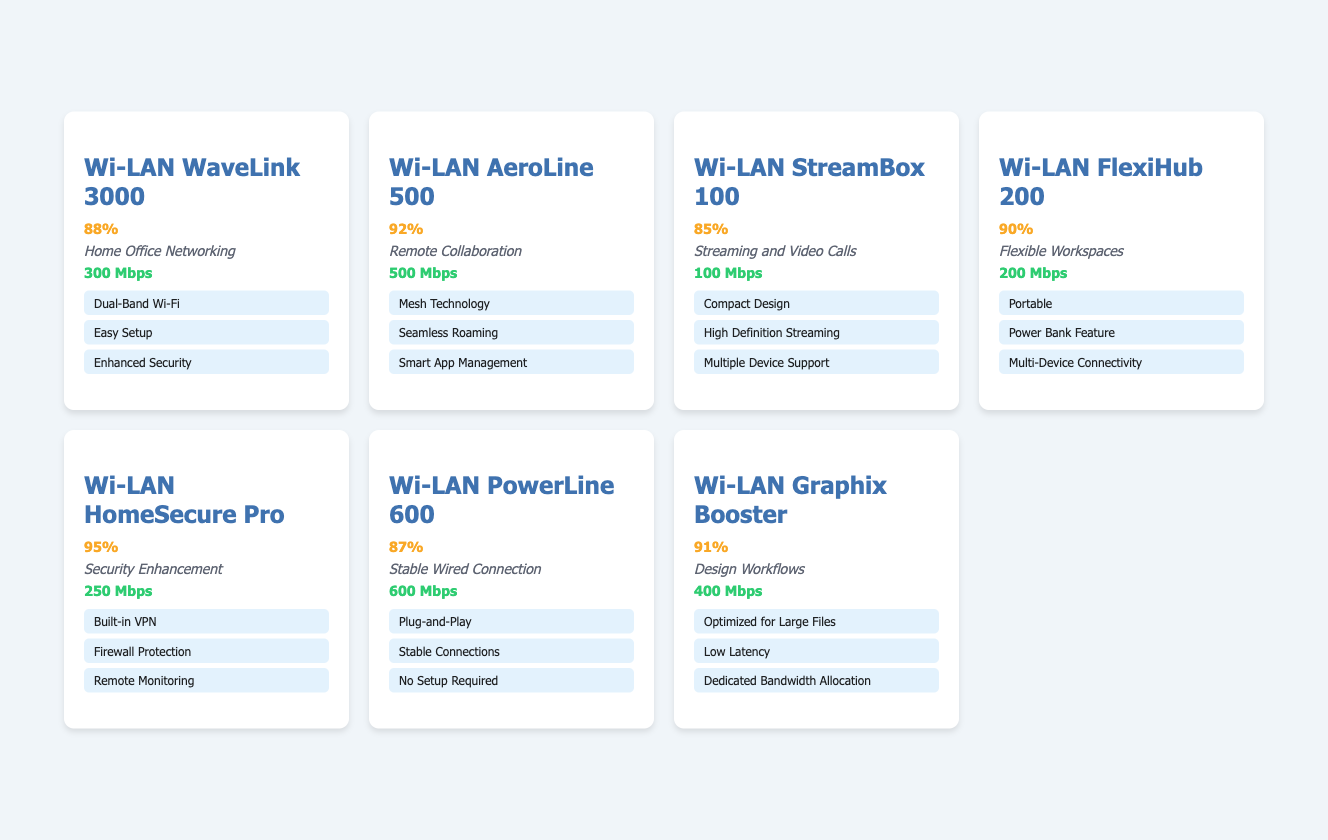What is the customer satisfaction rating for the Wi-LAN HomeSecure Pro? The table shows the customer satisfaction rating for each product. For the Wi-LAN HomeSecure Pro, the rating is presented as 95%.
Answer: 95% Which product has the highest customer satisfaction rating? By comparing the ratings in the table, the highest rating recorded is for the Wi-LAN HomeSecure Pro at 95%.
Answer: Wi-LAN HomeSecure Pro What is the average connectivity speed of the Wi-LAN FlexiHub 200? The average connectivity speed listed for the Wi-LAN FlexiHub 200 in the table is 200 Mbps, as stated next to the product details.
Answer: 200 Mbps How does the customer satisfaction rating of the Wi-LAN Graphix Booster compare to the Wi-LAN PowerLine 600? The customer satisfaction rating for the Wi-LAN Graphix Booster is 91%, while for the Wi-LAN PowerLine 600 it is 87%. The Graphix Booster has a higher rating than the PowerLine 600.
Answer: Higher If you average the customer satisfaction ratings of all products, what is the result? The customer satisfaction ratings are 88, 92, 85, 90, 95, 87, and 91. First, sum these ratings (88 + 92 + 85 + 90 + 95 + 87 + 91 = 718) and then divide by the number of products (7). So, the average is 718 / 7 = 102.57, which rounds to 102.57%.
Answer: 102.57 Is the Wi-LAN StreamBox 100 rated higher than the Wi-LAN WaveLink 3000? The customer satisfaction rating for the Wi-LAN StreamBox 100 is 85%, while for the Wi-LAN WaveLink 3000 it is 88%. Since 85% is less than 88%, the StreamBox 100 is not rated higher.
Answer: No Which two products have customer satisfaction ratings above 90%? The products with ratings above 90% are the Wi-LAN AeroLine 500 (92%) and the Wi-LAN HomeSecure Pro (95%). Thus, these are the two products that meet the criterion of having ratings above 90%.
Answer: AeroLine 500, HomeSecure Pro 